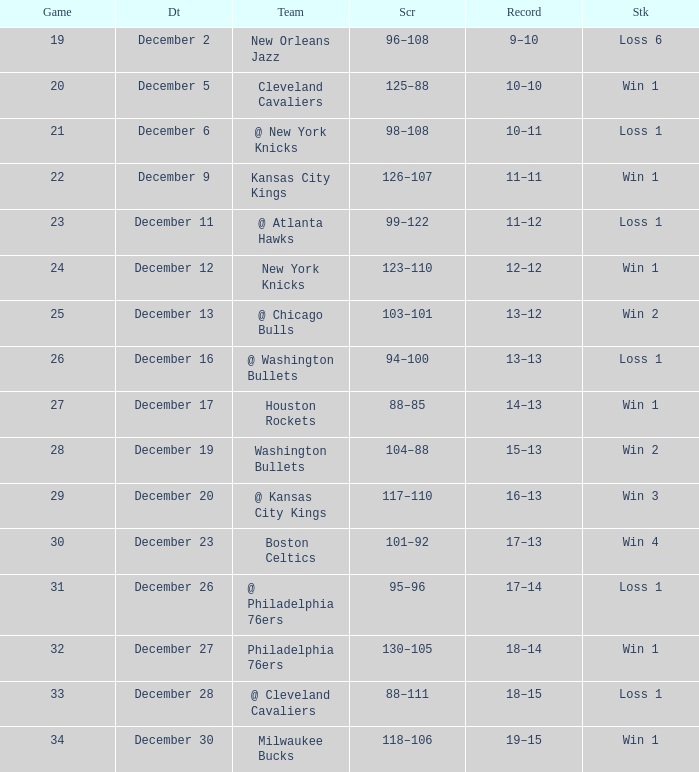What Game had a Score of 101–92? 30.0. 